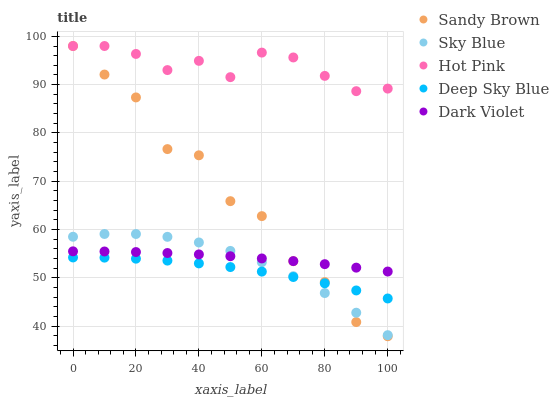Does Deep Sky Blue have the minimum area under the curve?
Answer yes or no. Yes. Does Hot Pink have the maximum area under the curve?
Answer yes or no. Yes. Does Sandy Brown have the minimum area under the curve?
Answer yes or no. No. Does Sandy Brown have the maximum area under the curve?
Answer yes or no. No. Is Dark Violet the smoothest?
Answer yes or no. Yes. Is Sandy Brown the roughest?
Answer yes or no. Yes. Is Hot Pink the smoothest?
Answer yes or no. No. Is Hot Pink the roughest?
Answer yes or no. No. Does Sandy Brown have the lowest value?
Answer yes or no. Yes. Does Hot Pink have the lowest value?
Answer yes or no. No. Does Sandy Brown have the highest value?
Answer yes or no. Yes. Does Dark Violet have the highest value?
Answer yes or no. No. Is Deep Sky Blue less than Dark Violet?
Answer yes or no. Yes. Is Hot Pink greater than Sky Blue?
Answer yes or no. Yes. Does Dark Violet intersect Sky Blue?
Answer yes or no. Yes. Is Dark Violet less than Sky Blue?
Answer yes or no. No. Is Dark Violet greater than Sky Blue?
Answer yes or no. No. Does Deep Sky Blue intersect Dark Violet?
Answer yes or no. No. 